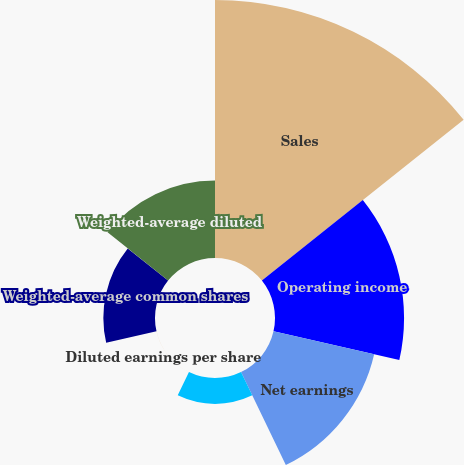<chart> <loc_0><loc_0><loc_500><loc_500><pie_chart><fcel>Sales<fcel>Operating income<fcel>Net earnings<fcel>Basic earnings per share<fcel>Diluted earnings per share<fcel>Weighted-average common shares<fcel>Weighted-average diluted<nl><fcel>39.98%<fcel>20.0%<fcel>16.0%<fcel>4.01%<fcel>0.01%<fcel>8.0%<fcel>12.0%<nl></chart> 